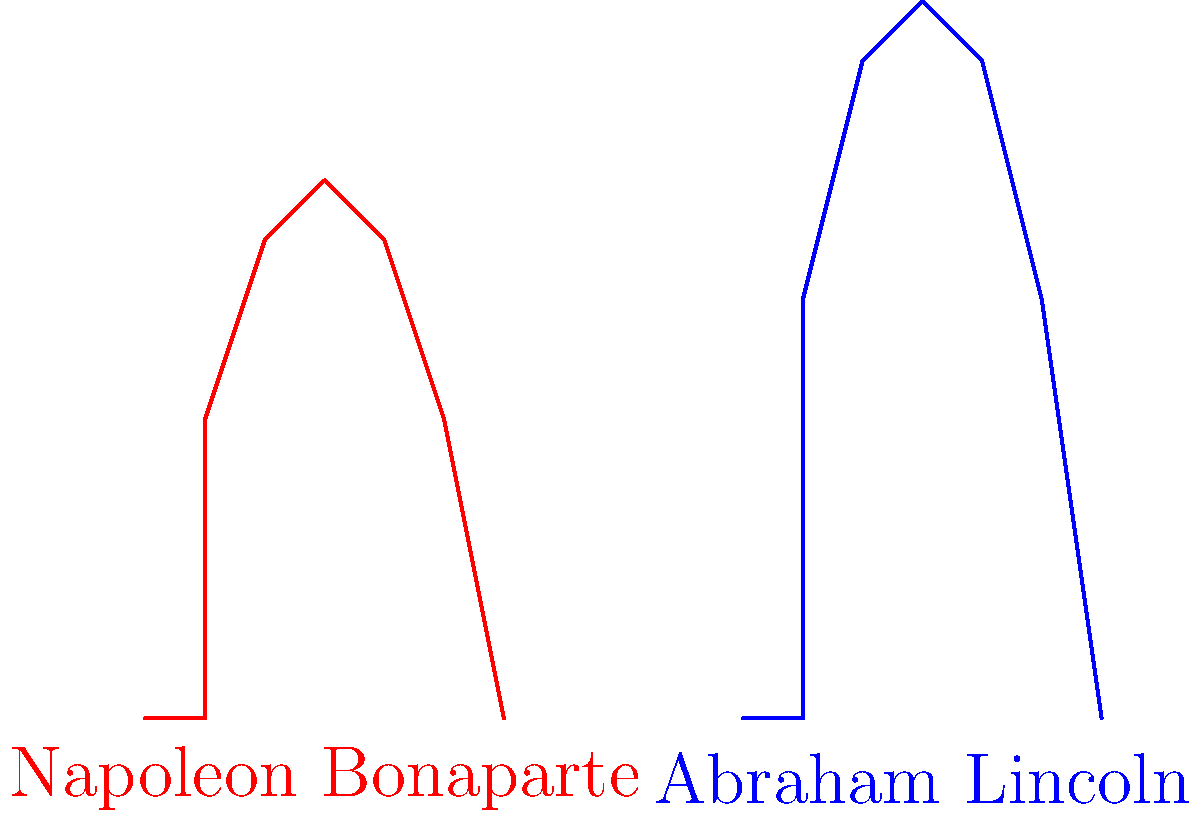Based on the silhouette graphics of Napoleon Bonaparte and Abraham Lincoln, which historical figure would likely have a longer stride length and why? To determine which historical figure would likely have a longer stride length, we need to consider their physical characteristics as shown in the silhouettes:

1. Height comparison:
   - Napoleon Bonaparte's silhouette is shorter and more compact.
   - Abraham Lincoln's silhouette is taller and more elongated.

2. Leg length:
   - Lincoln's legs appear proportionally longer than Napoleon's.
   - Longer legs generally correlate with a longer stride length.

3. Posture:
   - Lincoln's silhouette shows a more upright posture.
   - Napoleon's silhouette indicates a slightly more hunched posture.

4. Biomechanical principle:
   - Stride length is typically proportional to leg length.
   - The formula for stride length is often represented as:
     $SL = k \cdot L$
     Where $SL$ is stride length, $k$ is a constant, and $L$ is leg length.

5. Historical context:
   - Lincoln was known to be very tall (6'4" or 193 cm).
   - Napoleon was of average height for his time (5'6" or 168 cm).

Given these factors, Abraham Lincoln would likely have a longer stride length due to his greater height and longer legs. The biomechanical advantage of longer legs typically results in a longer natural stride, allowing for covering more ground with each step.
Answer: Abraham Lincoln, due to his greater height and longer legs. 